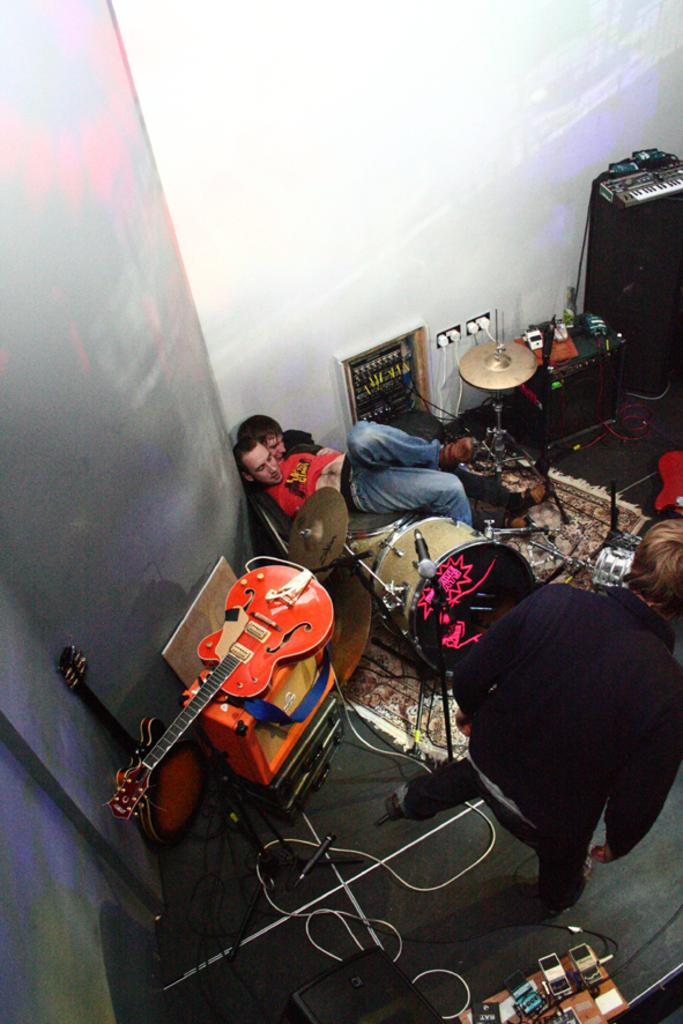What are the two guys in the image doing? The two guys are laying down in the image. What objects are in front of the guys? There are guitars and drums in front of the guys. Is there anyone else in the image besides the two guys? Yes, there is a man standing in the image. What type of bed is the man standing on in the image? There is no bed present in the image; the man is standing on the ground. 